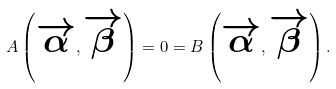<formula> <loc_0><loc_0><loc_500><loc_500>A \left ( \overrightarrow { \alpha } , \overrightarrow { \beta } \right ) = 0 = B \left ( \overrightarrow { \alpha } , \overrightarrow { \beta } \right ) .</formula> 